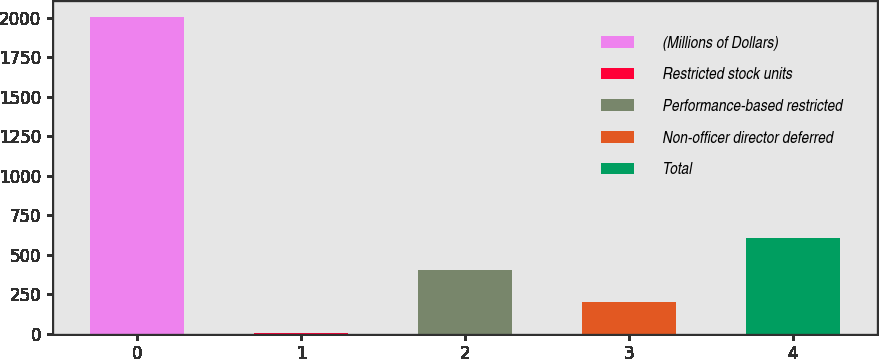Convert chart to OTSL. <chart><loc_0><loc_0><loc_500><loc_500><bar_chart><fcel>(Millions of Dollars)<fcel>Restricted stock units<fcel>Performance-based restricted<fcel>Non-officer director deferred<fcel>Total<nl><fcel>2006<fcel>1<fcel>402<fcel>201.5<fcel>602.5<nl></chart> 